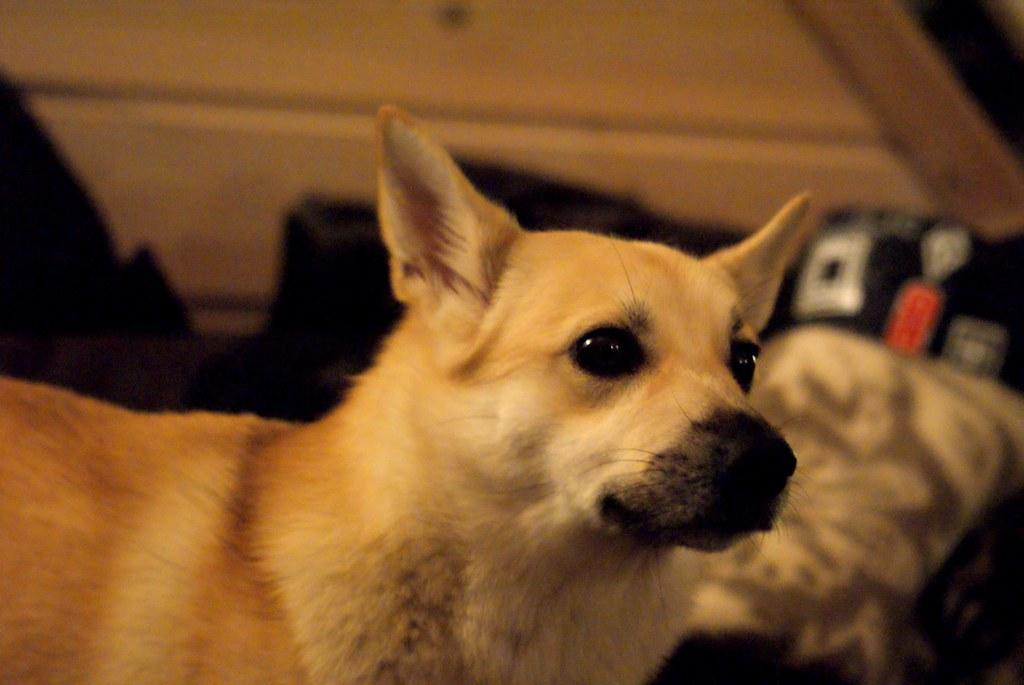What is the main subject in the center of the image? There is a dog in the center of the image. What can be seen in the background of the image? There is a wall visible in the background of the image. What type of stamp can be seen on the dog's collar in the image? There is no stamp visible on the dog's collar in the image, as the dog is not wearing a collar. 